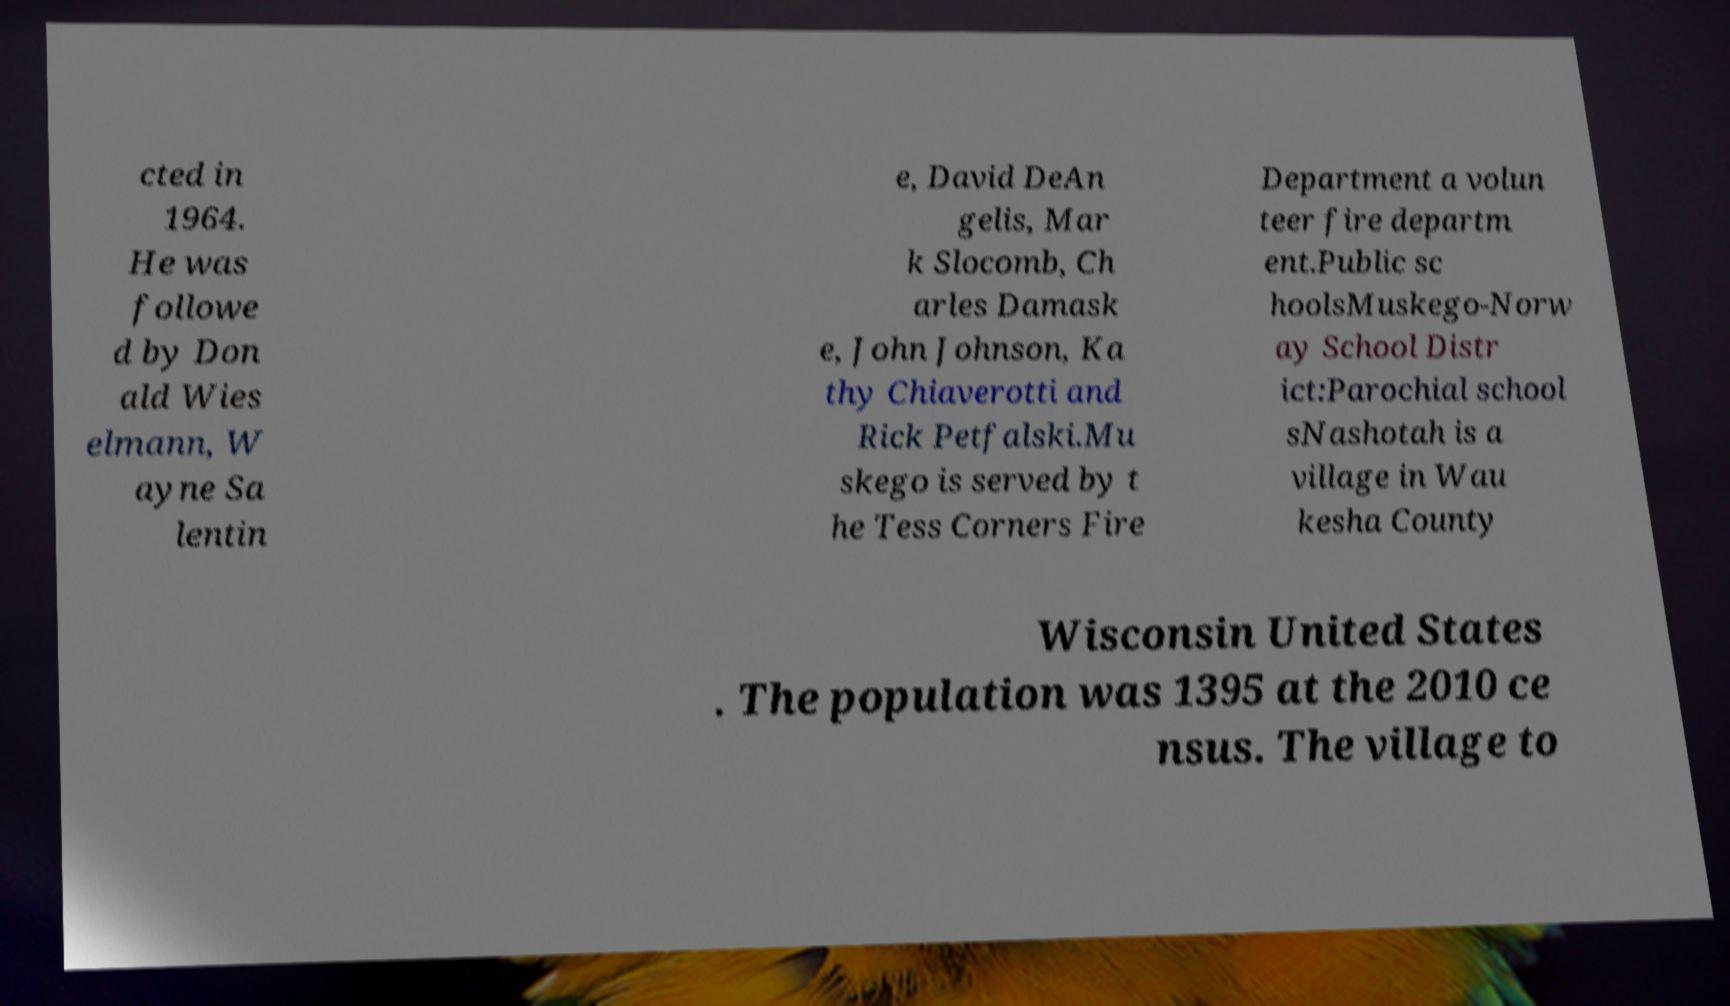There's text embedded in this image that I need extracted. Can you transcribe it verbatim? cted in 1964. He was followe d by Don ald Wies elmann, W ayne Sa lentin e, David DeAn gelis, Mar k Slocomb, Ch arles Damask e, John Johnson, Ka thy Chiaverotti and Rick Petfalski.Mu skego is served by t he Tess Corners Fire Department a volun teer fire departm ent.Public sc hoolsMuskego-Norw ay School Distr ict:Parochial school sNashotah is a village in Wau kesha County Wisconsin United States . The population was 1395 at the 2010 ce nsus. The village to 